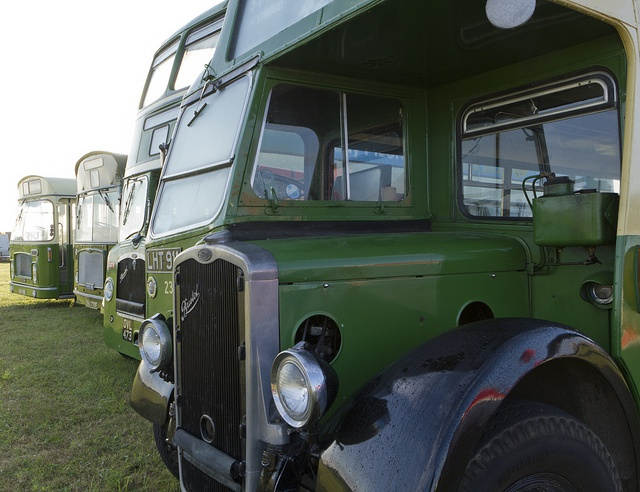Describe the objects in this image and their specific colors. I can see bus in black, white, gray, darkgreen, and darkgray tones, bus in white, darkgray, gray, and black tones, bus in white, darkgray, black, and gray tones, and bus in white, lightgray, darkgray, gray, and olive tones in this image. 